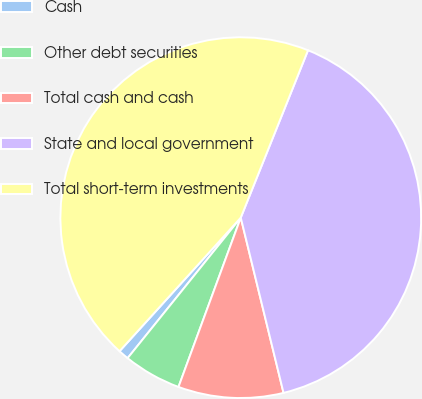Convert chart to OTSL. <chart><loc_0><loc_0><loc_500><loc_500><pie_chart><fcel>Cash<fcel>Other debt securities<fcel>Total cash and cash<fcel>State and local government<fcel>Total short-term investments<nl><fcel>0.94%<fcel>5.18%<fcel>9.42%<fcel>40.11%<fcel>44.35%<nl></chart> 